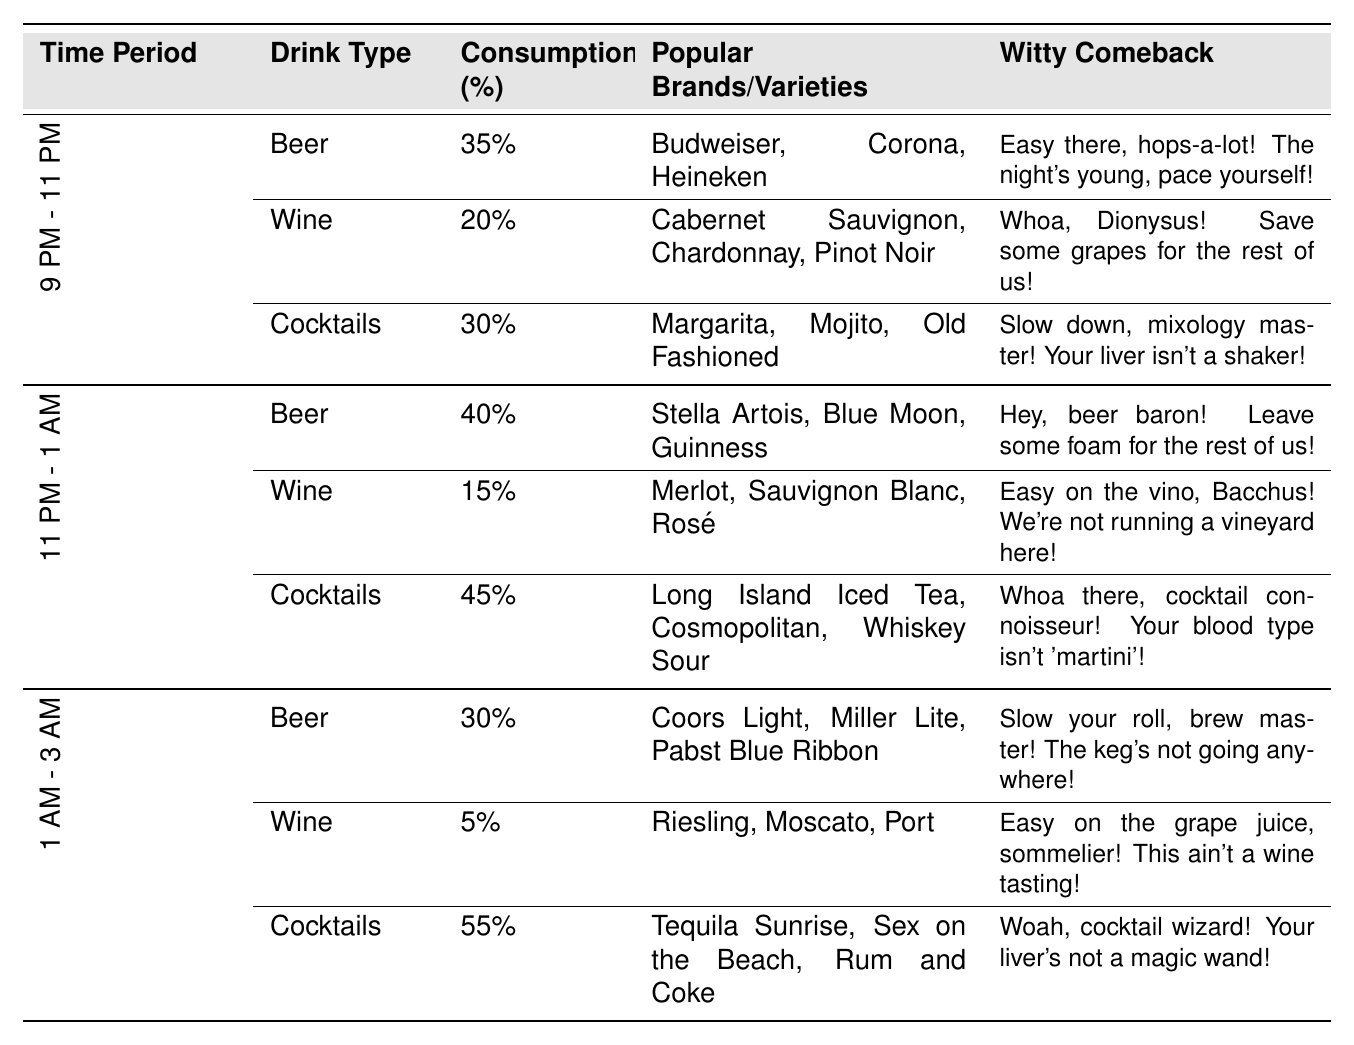What drink type has the highest consumption between 9 PM - 11 PM? The table shows that between 9 PM - 11 PM, Beer has the highest consumption at 35%.
Answer: Beer What is the total alcohol consumption for cocktails from 9 PM - 3 AM? The individual consumption for cocktails is 30% (9 PM - 11 PM) + 45% (11 PM - 1 AM) + 55% (1 AM - 3 AM) = 130%.
Answer: 130% At what time period do wine drinkers consume the least alcohol? The table shows that from 1 AM - 3 AM, wine consumption is the lowest at 5%.
Answer: 1 AM - 3 AM Is the consumption of cocktails higher than that of wine in the 11 PM - 1 AM period? The table states that cocktails have a consumption of 45% while wine has 15% in the 11 PM - 1 AM period. Since 45% is greater than 15%, the answer is yes.
Answer: Yes What is the average consumption of beer across the three time periods? The beer consumption is 35% (9 PM - 11 PM), 40% (11 PM - 1 AM), and 30% (1 AM - 3 AM). To find the average, sum these values (35 + 40 + 30 = 105) and divide by 3, giving an average of 105 / 3 = 35%.
Answer: 35% Which time period has the highest overall cocktail consumption? The cocktail consumption values are 30% (9 PM - 11 PM), 45% (11 PM - 1 AM), and 55% (1 AM - 3 AM). The highest among these is 55% during the 1 AM - 3 AM period.
Answer: 1 AM - 3 AM Was the overall wine consumption higher in the period of 9 PM - 11 PM compared to 1 AM - 3 AM? The wine consumption is 20% (9 PM - 11 PM) vs. 5% (1 AM - 3 AM). Since 20% is greater than 5%, the answer is yes.
Answer: Yes How much more beer was consumed from 11 PM - 1 AM compared to 1 AM - 3 AM? Beer consumption from 11 PM - 1 AM is 40%, while from 1 AM - 3 AM it is 30%. The difference is 40% - 30% = 10%.
Answer: 10% Which drink type had the highest increase in consumption from 9 PM - 11 PM to 11 PM - 1 AM? Beer increased from 35% to 40% (an increase of 5%), Wine decreased from 20% to 15% (a decrease of 5%), and Cocktails increased from 30% to 45% (an increase of 15%). So, Cocktails had the highest increase of 15%.
Answer: Cocktails What is the percentage of total alcoholic beverages consumed (Beer, Wine, Cocktails) from 1 AM - 3 AM? The table lists Beer (30%), Wine (5%), and Cocktails (55%) for this time period. Total consumption is 30 + 5 + 55 = 90%.
Answer: 90% 